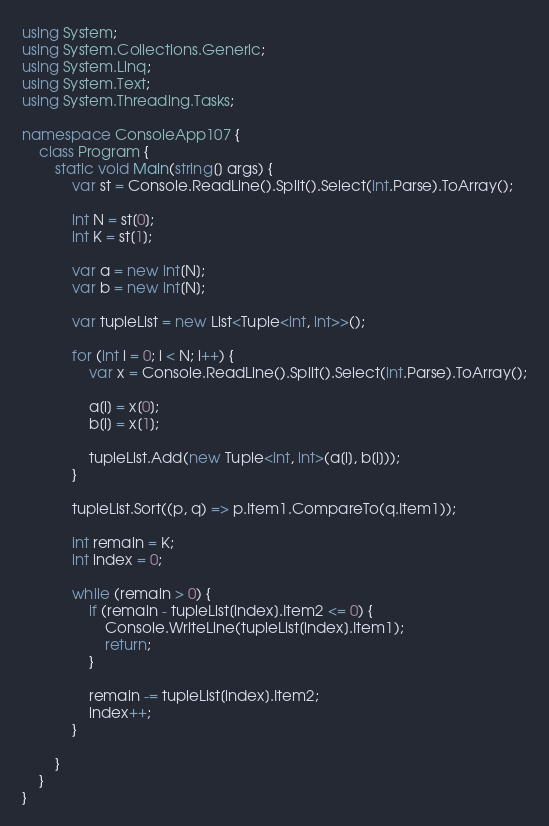Convert code to text. <code><loc_0><loc_0><loc_500><loc_500><_C#_>using System;
using System.Collections.Generic;
using System.Linq;
using System.Text;
using System.Threading.Tasks;

namespace ConsoleApp107 {
    class Program {
        static void Main(string[] args) {
            var st = Console.ReadLine().Split().Select(int.Parse).ToArray();

            int N = st[0];
            int K = st[1];

            var a = new int[N];
            var b = new int[N];

            var tupleList = new List<Tuple<int, int>>();

            for (int i = 0; i < N; i++) {
                var x = Console.ReadLine().Split().Select(int.Parse).ToArray();

                a[i] = x[0];
                b[i] = x[1];

                tupleList.Add(new Tuple<int, int>(a[i], b[i]));
            }

            tupleList.Sort((p, q) => p.Item1.CompareTo(q.Item1));

            int remain = K;
            int index = 0;

            while (remain > 0) {
                if (remain - tupleList[index].Item2 <= 0) {
                    Console.WriteLine(tupleList[index].Item1);
                    return;
                }

                remain -= tupleList[index].Item2;
                index++;
            }

        }
    }
}
</code> 